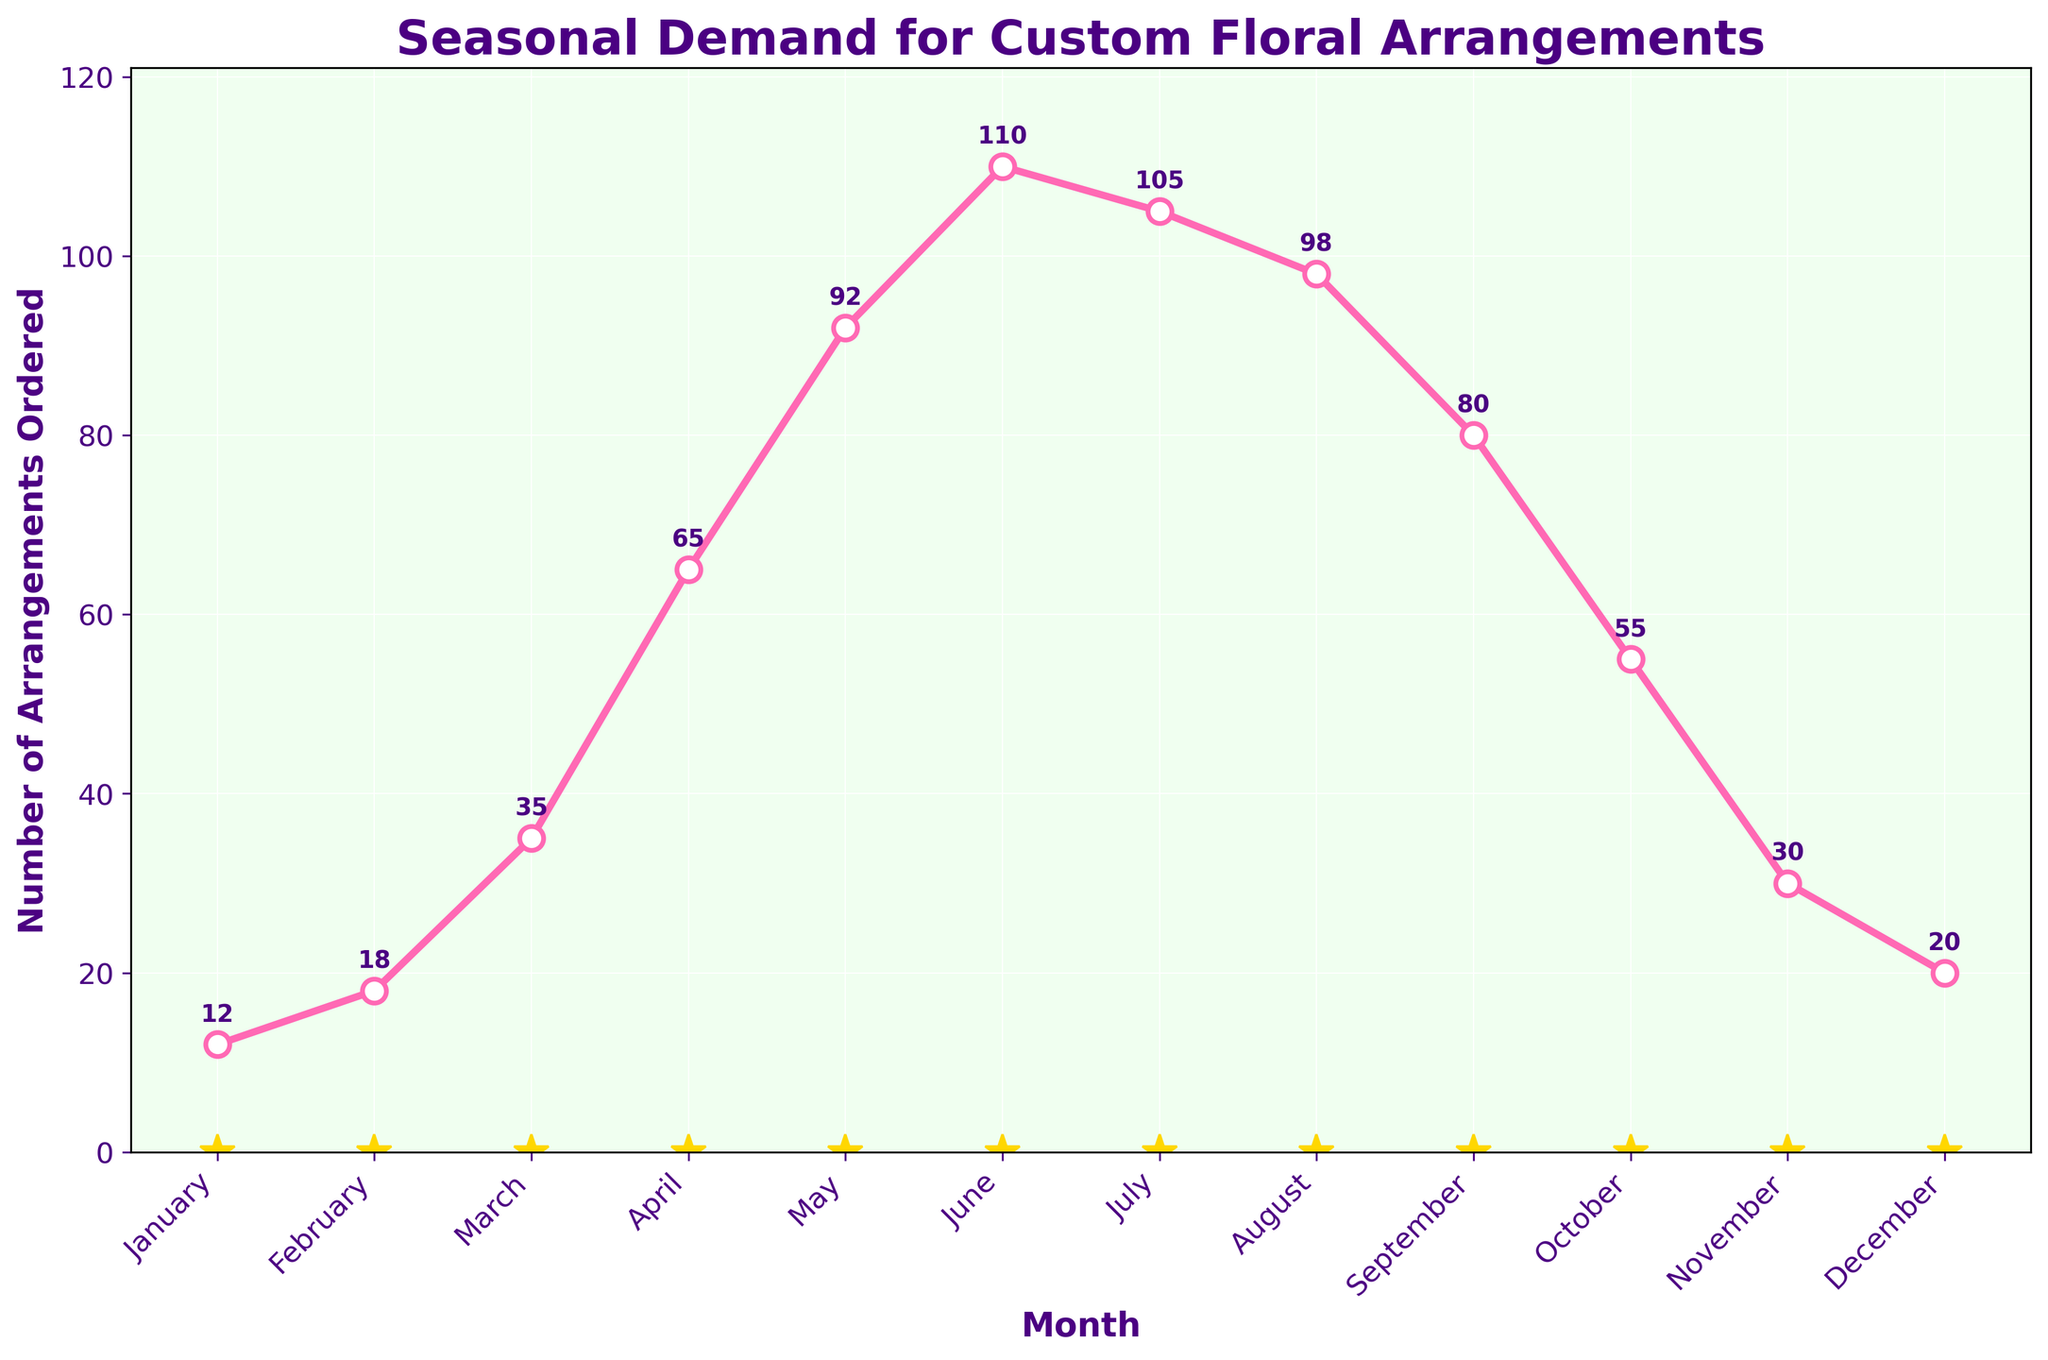What is the overall trend in demand for custom floral arrangements from January to December? The overall trend in the number of custom floral arrangements ordered shows a gradual increase from January to June, peaking in June, after which there is a gradual decrease from July to December.
Answer: Gradual increase to June, then decrease Which month has the highest number of custom floral arrangements ordered? Observing the plot, June has the highest point on the line, indicating the peak number of custom floral arrangements ordered.
Answer: June How does the demand in March compare to the demand in September? The plot shows that March has 35 arrangements ordered, while September has 80 arrangements. March has significantly fewer orders than September.
Answer: March has fewer orders What is the difference in the number of arrangements ordered between May and December? According to the plot, May has 92 arrangements ordered and December has 20. The difference is 92 - 20 = 72.
Answer: 72 Which two consecutive months show the greatest increase in demand? The plot shows that the greatest increase in demand occurs between March and April, where the number of arrangements ordered jumps from 35 to 65.
Answer: March to April What is the average number of custom floral arrangements ordered in the first half of the year (January to June)? Adding up the orders for January through June (12 + 18 + 35 + 65 + 92 + 110) equals 332. Dividing by 6 gives the average: 332 / 6 ≈ 55.33.
Answer: 55.33 By how much does the number of arrangements ordered decrease from June to July? The plot shows that June has 110 orders and July has 105. The decrease is 110 - 105 = 5.
Answer: 5 What visual feature indicates the addition of value labels on the plot? The plot has numerical values positioned slightly above each marker point on the line, showing the exact number of orders for each month.
Answer: Numerical values above points How much more demand was there in the peak month compared to the lowest demand month? The peak month is June with 110 orders, and the lowest demand month is January with 12 orders. The difference is 110 - 12 = 98.
Answer: 98 